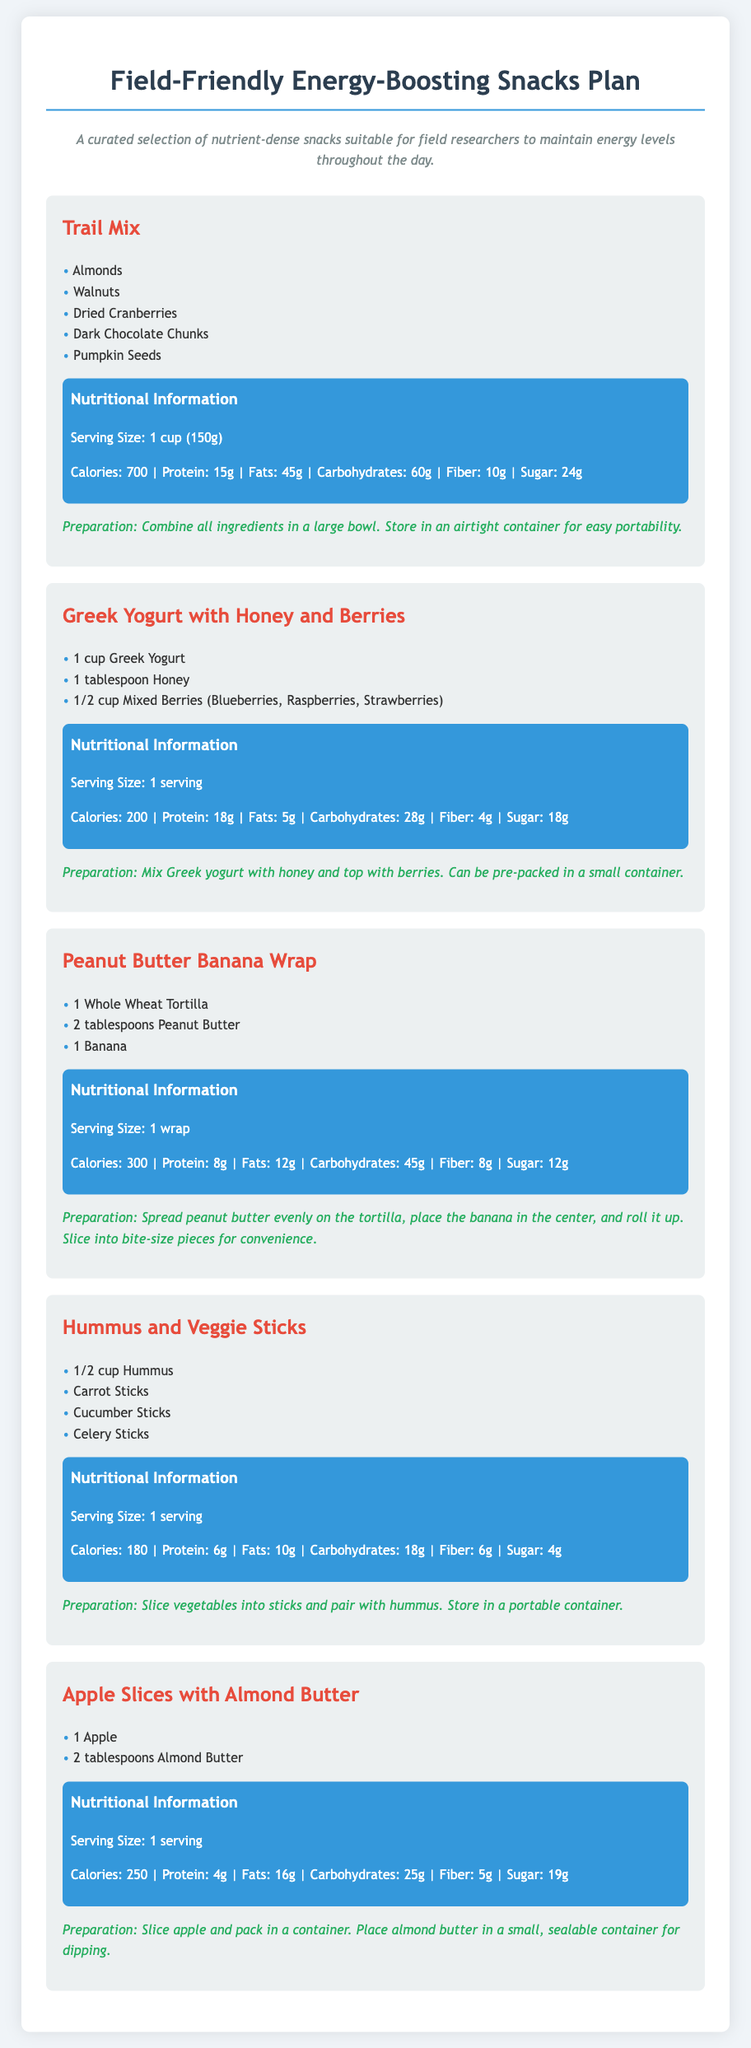What is the serving size for Trail Mix? The serving size for Trail Mix is provided in the nutritional information section.
Answer: 1 cup (150g) How many grams of protein are in Greek Yogurt with Honey and Berries? The protein content is specified in the nutritional information section of the snack.
Answer: 18g What snack contains pumpkin seeds? The snack names are listed in the document, and pumpkin seeds are an ingredient for Trail Mix.
Answer: Trail Mix What is the caloric content of the Peanut Butter Banana Wrap? The calorie count is found in the nutritional information of the snack.
Answer: 300 How many ingredients are listed for Hummus and Veggie Sticks? The ingredients are shown as a list, and the total count is relevant for this question.
Answer: 4 What type of tortilla is used in the Peanut Butter Banana Wrap? The type of tortilla is mentioned in the ingredients section specific to this snack.
Answer: Whole Wheat Tortilla What snack has the highest fat content? You need to compare the fat content across the various snacks to find the highest value.
Answer: Trail Mix How should Apple Slices with Almond Butter be prepared? The preparation tips describe how to prepare each snack, specifically for this one.
Answer: Slice apple and pack in a container 